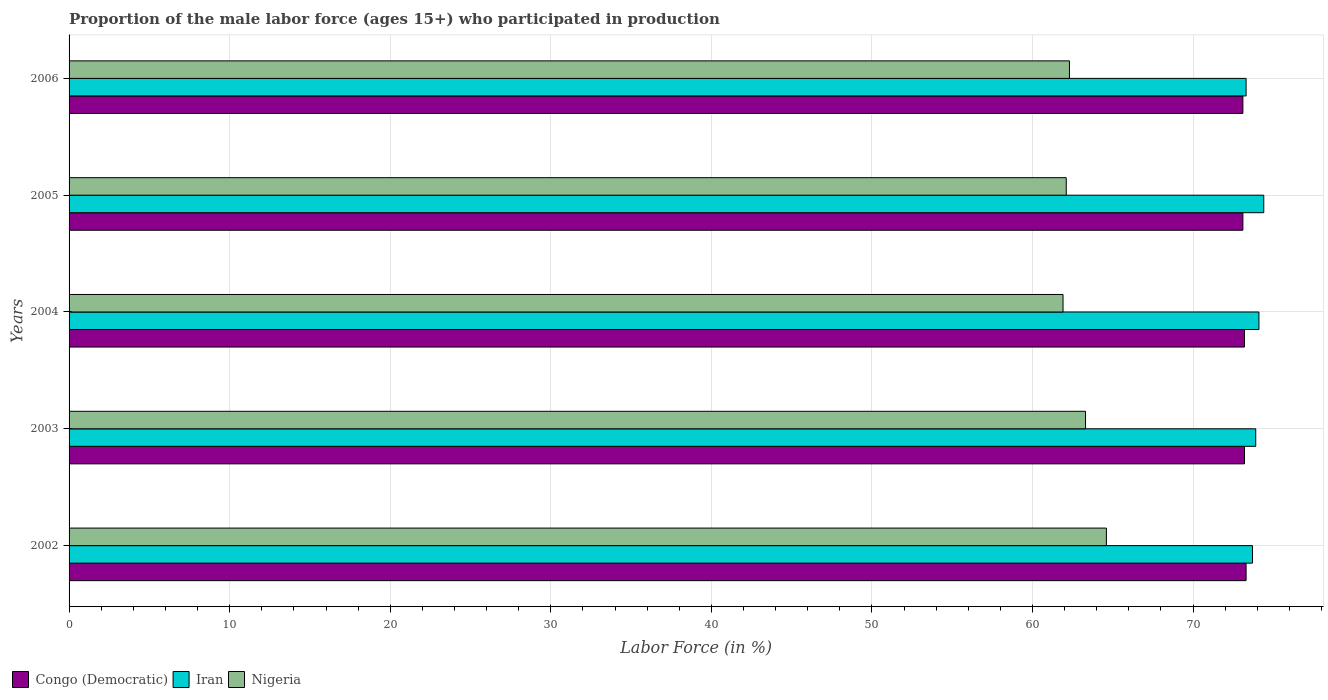How many different coloured bars are there?
Provide a short and direct response. 3. Are the number of bars per tick equal to the number of legend labels?
Offer a very short reply. Yes. Are the number of bars on each tick of the Y-axis equal?
Make the answer very short. Yes. How many bars are there on the 3rd tick from the bottom?
Make the answer very short. 3. What is the label of the 5th group of bars from the top?
Provide a short and direct response. 2002. In how many cases, is the number of bars for a given year not equal to the number of legend labels?
Keep it short and to the point. 0. What is the proportion of the male labor force who participated in production in Congo (Democratic) in 2005?
Ensure brevity in your answer.  73.1. Across all years, what is the maximum proportion of the male labor force who participated in production in Nigeria?
Give a very brief answer. 64.6. Across all years, what is the minimum proportion of the male labor force who participated in production in Congo (Democratic)?
Make the answer very short. 73.1. In which year was the proportion of the male labor force who participated in production in Iran maximum?
Give a very brief answer. 2005. What is the total proportion of the male labor force who participated in production in Nigeria in the graph?
Keep it short and to the point. 314.2. What is the difference between the proportion of the male labor force who participated in production in Congo (Democratic) in 2002 and that in 2005?
Make the answer very short. 0.2. What is the difference between the proportion of the male labor force who participated in production in Congo (Democratic) in 2004 and the proportion of the male labor force who participated in production in Nigeria in 2002?
Your response must be concise. 8.6. What is the average proportion of the male labor force who participated in production in Nigeria per year?
Offer a terse response. 62.84. In the year 2004, what is the difference between the proportion of the male labor force who participated in production in Congo (Democratic) and proportion of the male labor force who participated in production in Nigeria?
Offer a very short reply. 11.3. In how many years, is the proportion of the male labor force who participated in production in Congo (Democratic) greater than 36 %?
Your answer should be compact. 5. What is the ratio of the proportion of the male labor force who participated in production in Nigeria in 2003 to that in 2005?
Keep it short and to the point. 1.02. What is the difference between the highest and the second highest proportion of the male labor force who participated in production in Congo (Democratic)?
Give a very brief answer. 0.1. What is the difference between the highest and the lowest proportion of the male labor force who participated in production in Nigeria?
Ensure brevity in your answer.  2.7. In how many years, is the proportion of the male labor force who participated in production in Nigeria greater than the average proportion of the male labor force who participated in production in Nigeria taken over all years?
Provide a succinct answer. 2. What does the 1st bar from the top in 2002 represents?
Your answer should be very brief. Nigeria. What does the 1st bar from the bottom in 2006 represents?
Provide a succinct answer. Congo (Democratic). Are all the bars in the graph horizontal?
Make the answer very short. Yes. How many years are there in the graph?
Provide a short and direct response. 5. What is the difference between two consecutive major ticks on the X-axis?
Your answer should be compact. 10. Are the values on the major ticks of X-axis written in scientific E-notation?
Make the answer very short. No. Does the graph contain any zero values?
Offer a very short reply. No. Does the graph contain grids?
Offer a very short reply. Yes. How are the legend labels stacked?
Give a very brief answer. Horizontal. What is the title of the graph?
Offer a terse response. Proportion of the male labor force (ages 15+) who participated in production. What is the label or title of the Y-axis?
Ensure brevity in your answer.  Years. What is the Labor Force (in %) in Congo (Democratic) in 2002?
Make the answer very short. 73.3. What is the Labor Force (in %) of Iran in 2002?
Your answer should be compact. 73.7. What is the Labor Force (in %) of Nigeria in 2002?
Your response must be concise. 64.6. What is the Labor Force (in %) in Congo (Democratic) in 2003?
Provide a short and direct response. 73.2. What is the Labor Force (in %) of Iran in 2003?
Your response must be concise. 73.9. What is the Labor Force (in %) of Nigeria in 2003?
Your answer should be compact. 63.3. What is the Labor Force (in %) in Congo (Democratic) in 2004?
Your answer should be very brief. 73.2. What is the Labor Force (in %) in Iran in 2004?
Your response must be concise. 74.1. What is the Labor Force (in %) of Nigeria in 2004?
Your answer should be compact. 61.9. What is the Labor Force (in %) in Congo (Democratic) in 2005?
Your response must be concise. 73.1. What is the Labor Force (in %) in Iran in 2005?
Ensure brevity in your answer.  74.4. What is the Labor Force (in %) of Nigeria in 2005?
Offer a terse response. 62.1. What is the Labor Force (in %) in Congo (Democratic) in 2006?
Your response must be concise. 73.1. What is the Labor Force (in %) in Iran in 2006?
Your response must be concise. 73.3. What is the Labor Force (in %) of Nigeria in 2006?
Make the answer very short. 62.3. Across all years, what is the maximum Labor Force (in %) of Congo (Democratic)?
Your answer should be compact. 73.3. Across all years, what is the maximum Labor Force (in %) of Iran?
Your response must be concise. 74.4. Across all years, what is the maximum Labor Force (in %) in Nigeria?
Provide a succinct answer. 64.6. Across all years, what is the minimum Labor Force (in %) of Congo (Democratic)?
Make the answer very short. 73.1. Across all years, what is the minimum Labor Force (in %) of Iran?
Your response must be concise. 73.3. Across all years, what is the minimum Labor Force (in %) of Nigeria?
Provide a short and direct response. 61.9. What is the total Labor Force (in %) in Congo (Democratic) in the graph?
Provide a succinct answer. 365.9. What is the total Labor Force (in %) in Iran in the graph?
Provide a short and direct response. 369.4. What is the total Labor Force (in %) in Nigeria in the graph?
Offer a very short reply. 314.2. What is the difference between the Labor Force (in %) of Congo (Democratic) in 2002 and that in 2003?
Offer a terse response. 0.1. What is the difference between the Labor Force (in %) of Congo (Democratic) in 2002 and that in 2004?
Your answer should be very brief. 0.1. What is the difference between the Labor Force (in %) in Iran in 2002 and that in 2004?
Offer a very short reply. -0.4. What is the difference between the Labor Force (in %) in Nigeria in 2002 and that in 2004?
Your answer should be compact. 2.7. What is the difference between the Labor Force (in %) of Iran in 2002 and that in 2005?
Your answer should be compact. -0.7. What is the difference between the Labor Force (in %) in Nigeria in 2002 and that in 2005?
Keep it short and to the point. 2.5. What is the difference between the Labor Force (in %) in Congo (Democratic) in 2002 and that in 2006?
Give a very brief answer. 0.2. What is the difference between the Labor Force (in %) of Congo (Democratic) in 2003 and that in 2004?
Offer a terse response. 0. What is the difference between the Labor Force (in %) in Iran in 2003 and that in 2004?
Provide a short and direct response. -0.2. What is the difference between the Labor Force (in %) of Nigeria in 2003 and that in 2004?
Give a very brief answer. 1.4. What is the difference between the Labor Force (in %) in Nigeria in 2003 and that in 2005?
Provide a succinct answer. 1.2. What is the difference between the Labor Force (in %) in Nigeria in 2003 and that in 2006?
Offer a very short reply. 1. What is the difference between the Labor Force (in %) in Congo (Democratic) in 2004 and that in 2005?
Provide a succinct answer. 0.1. What is the difference between the Labor Force (in %) in Iran in 2004 and that in 2005?
Your response must be concise. -0.3. What is the difference between the Labor Force (in %) in Nigeria in 2004 and that in 2005?
Provide a short and direct response. -0.2. What is the difference between the Labor Force (in %) of Nigeria in 2004 and that in 2006?
Offer a very short reply. -0.4. What is the difference between the Labor Force (in %) in Congo (Democratic) in 2005 and that in 2006?
Provide a succinct answer. 0. What is the difference between the Labor Force (in %) in Iran in 2005 and that in 2006?
Make the answer very short. 1.1. What is the difference between the Labor Force (in %) in Iran in 2002 and the Labor Force (in %) in Nigeria in 2003?
Make the answer very short. 10.4. What is the difference between the Labor Force (in %) in Congo (Democratic) in 2002 and the Labor Force (in %) in Iran in 2004?
Make the answer very short. -0.8. What is the difference between the Labor Force (in %) in Congo (Democratic) in 2002 and the Labor Force (in %) in Nigeria in 2004?
Provide a short and direct response. 11.4. What is the difference between the Labor Force (in %) of Iran in 2002 and the Labor Force (in %) of Nigeria in 2004?
Offer a very short reply. 11.8. What is the difference between the Labor Force (in %) of Congo (Democratic) in 2002 and the Labor Force (in %) of Iran in 2005?
Provide a short and direct response. -1.1. What is the difference between the Labor Force (in %) in Congo (Democratic) in 2002 and the Labor Force (in %) in Nigeria in 2005?
Your answer should be very brief. 11.2. What is the difference between the Labor Force (in %) of Iran in 2002 and the Labor Force (in %) of Nigeria in 2005?
Give a very brief answer. 11.6. What is the difference between the Labor Force (in %) in Congo (Democratic) in 2002 and the Labor Force (in %) in Iran in 2006?
Offer a terse response. 0. What is the difference between the Labor Force (in %) in Congo (Democratic) in 2002 and the Labor Force (in %) in Nigeria in 2006?
Offer a terse response. 11. What is the difference between the Labor Force (in %) of Iran in 2002 and the Labor Force (in %) of Nigeria in 2006?
Offer a terse response. 11.4. What is the difference between the Labor Force (in %) of Congo (Democratic) in 2003 and the Labor Force (in %) of Iran in 2004?
Make the answer very short. -0.9. What is the difference between the Labor Force (in %) in Iran in 2003 and the Labor Force (in %) in Nigeria in 2004?
Provide a short and direct response. 12. What is the difference between the Labor Force (in %) of Iran in 2003 and the Labor Force (in %) of Nigeria in 2005?
Provide a short and direct response. 11.8. What is the difference between the Labor Force (in %) in Congo (Democratic) in 2003 and the Labor Force (in %) in Iran in 2006?
Ensure brevity in your answer.  -0.1. What is the difference between the Labor Force (in %) in Congo (Democratic) in 2003 and the Labor Force (in %) in Nigeria in 2006?
Provide a short and direct response. 10.9. What is the difference between the Labor Force (in %) in Congo (Democratic) in 2004 and the Labor Force (in %) in Nigeria in 2005?
Offer a terse response. 11.1. What is the difference between the Labor Force (in %) of Iran in 2004 and the Labor Force (in %) of Nigeria in 2005?
Ensure brevity in your answer.  12. What is the difference between the Labor Force (in %) of Congo (Democratic) in 2004 and the Labor Force (in %) of Iran in 2006?
Your answer should be very brief. -0.1. What is the difference between the Labor Force (in %) in Iran in 2004 and the Labor Force (in %) in Nigeria in 2006?
Offer a terse response. 11.8. What is the difference between the Labor Force (in %) in Iran in 2005 and the Labor Force (in %) in Nigeria in 2006?
Give a very brief answer. 12.1. What is the average Labor Force (in %) in Congo (Democratic) per year?
Ensure brevity in your answer.  73.18. What is the average Labor Force (in %) in Iran per year?
Provide a succinct answer. 73.88. What is the average Labor Force (in %) of Nigeria per year?
Provide a short and direct response. 62.84. In the year 2002, what is the difference between the Labor Force (in %) of Congo (Democratic) and Labor Force (in %) of Iran?
Provide a succinct answer. -0.4. In the year 2002, what is the difference between the Labor Force (in %) of Congo (Democratic) and Labor Force (in %) of Nigeria?
Your answer should be very brief. 8.7. In the year 2003, what is the difference between the Labor Force (in %) in Congo (Democratic) and Labor Force (in %) in Iran?
Ensure brevity in your answer.  -0.7. In the year 2003, what is the difference between the Labor Force (in %) in Congo (Democratic) and Labor Force (in %) in Nigeria?
Provide a short and direct response. 9.9. In the year 2003, what is the difference between the Labor Force (in %) of Iran and Labor Force (in %) of Nigeria?
Offer a very short reply. 10.6. In the year 2005, what is the difference between the Labor Force (in %) in Iran and Labor Force (in %) in Nigeria?
Offer a terse response. 12.3. In the year 2006, what is the difference between the Labor Force (in %) in Iran and Labor Force (in %) in Nigeria?
Your answer should be compact. 11. What is the ratio of the Labor Force (in %) of Nigeria in 2002 to that in 2003?
Give a very brief answer. 1.02. What is the ratio of the Labor Force (in %) in Iran in 2002 to that in 2004?
Make the answer very short. 0.99. What is the ratio of the Labor Force (in %) of Nigeria in 2002 to that in 2004?
Provide a short and direct response. 1.04. What is the ratio of the Labor Force (in %) of Iran in 2002 to that in 2005?
Your response must be concise. 0.99. What is the ratio of the Labor Force (in %) of Nigeria in 2002 to that in 2005?
Offer a very short reply. 1.04. What is the ratio of the Labor Force (in %) in Congo (Democratic) in 2002 to that in 2006?
Provide a succinct answer. 1. What is the ratio of the Labor Force (in %) of Nigeria in 2002 to that in 2006?
Offer a very short reply. 1.04. What is the ratio of the Labor Force (in %) in Congo (Democratic) in 2003 to that in 2004?
Keep it short and to the point. 1. What is the ratio of the Labor Force (in %) of Iran in 2003 to that in 2004?
Your answer should be very brief. 1. What is the ratio of the Labor Force (in %) of Nigeria in 2003 to that in 2004?
Make the answer very short. 1.02. What is the ratio of the Labor Force (in %) of Congo (Democratic) in 2003 to that in 2005?
Give a very brief answer. 1. What is the ratio of the Labor Force (in %) of Nigeria in 2003 to that in 2005?
Ensure brevity in your answer.  1.02. What is the ratio of the Labor Force (in %) of Congo (Democratic) in 2003 to that in 2006?
Make the answer very short. 1. What is the ratio of the Labor Force (in %) in Iran in 2003 to that in 2006?
Give a very brief answer. 1.01. What is the ratio of the Labor Force (in %) in Nigeria in 2003 to that in 2006?
Offer a very short reply. 1.02. What is the ratio of the Labor Force (in %) in Iran in 2004 to that in 2005?
Make the answer very short. 1. What is the ratio of the Labor Force (in %) of Congo (Democratic) in 2004 to that in 2006?
Offer a very short reply. 1. What is the ratio of the Labor Force (in %) in Iran in 2004 to that in 2006?
Give a very brief answer. 1.01. What is the ratio of the Labor Force (in %) of Nigeria in 2005 to that in 2006?
Provide a succinct answer. 1. What is the difference between the highest and the second highest Labor Force (in %) of Iran?
Your response must be concise. 0.3. What is the difference between the highest and the lowest Labor Force (in %) of Iran?
Provide a short and direct response. 1.1. What is the difference between the highest and the lowest Labor Force (in %) of Nigeria?
Your answer should be compact. 2.7. 